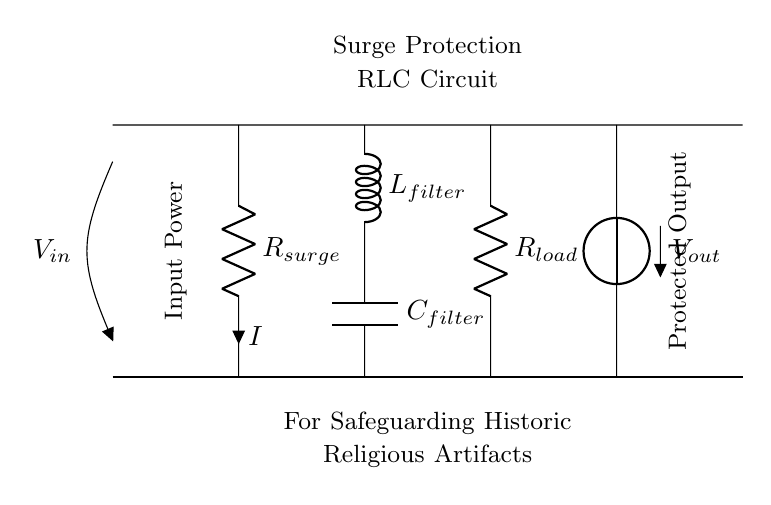What is the input voltage for this circuit? The circuit shows an open terminal labeled with V_in at the left, indicating this is the input voltage.
Answer: V_in What are the components used in this circuit? The circuit diagram includes a resistor, an inductor, and a capacitor, which are common components in RLC circuits. Specifically, it has R_sur, L_filter, and C_filter.
Answer: Resistor, Inductor, Capacitor What is the purpose of R_sur? R_sur, labeled as surge protection, is designed to limit the current during surge conditions, thereby protecting the rest of the circuit and the connected loads.
Answer: Current limiting What role does L_filter play in this circuit? L_filter is part of the filter section responsible for smoothing out fluctuations in the current, allowing for better voltage stability and reducing spikes caused by surges.
Answer: Voltage stabilization How does C_filter interact with L_filter? C_filter works in conjunction with L_filter to form a low-pass filter, which allows normal frequencies through while attenuating high-frequency noise or spikes present during power fluctuations.
Answer: Low-pass filter What is the significance of the connection between R_load and V_out? The connection signifies that R_load receives the output voltage V_out, which is the voltage delivered to the protected output, indicating that this component is crucial for the operation of the load.
Answer: Protected output voltage 